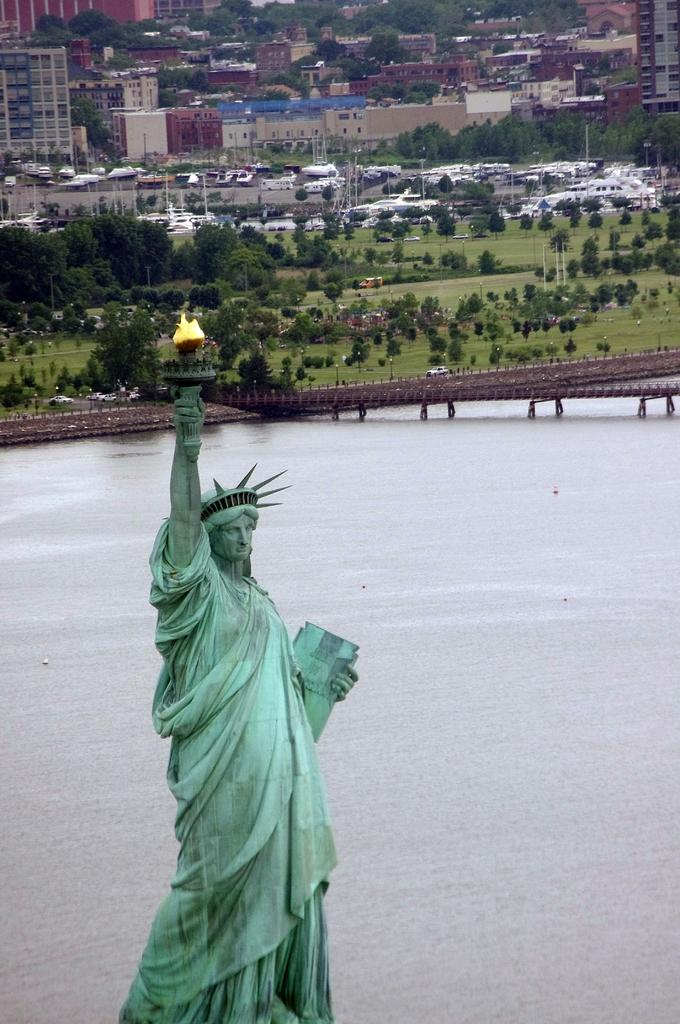What is the main subject of the image? The image shows an aerial view of the Statue of Liberty. What can be seen behind the Statue of Liberty? There is water visible behind the Statue of Liberty. What type of vehicles can be seen in the image? Cars are visible in the image. What type of natural elements are present in the image? Trees are present in the image. What type of man-made structures can be seen in the image? There are house buildings in the image. What room is the achiever sitting in while looking at the base of the Statue of Liberty? There is no achiever or room present in the image; it is an aerial view of the Statue of Liberty. 